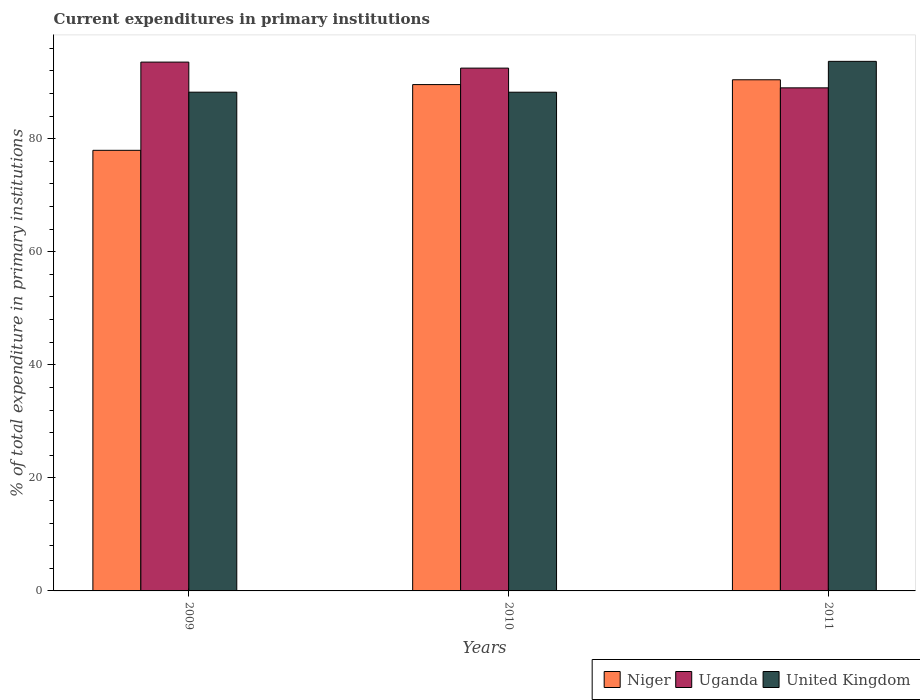How many different coloured bars are there?
Ensure brevity in your answer.  3. How many groups of bars are there?
Offer a very short reply. 3. Are the number of bars per tick equal to the number of legend labels?
Your answer should be compact. Yes. Are the number of bars on each tick of the X-axis equal?
Make the answer very short. Yes. How many bars are there on the 2nd tick from the left?
Your answer should be very brief. 3. How many bars are there on the 2nd tick from the right?
Keep it short and to the point. 3. What is the label of the 1st group of bars from the left?
Your response must be concise. 2009. What is the current expenditures in primary institutions in Uganda in 2010?
Ensure brevity in your answer.  92.48. Across all years, what is the maximum current expenditures in primary institutions in Niger?
Your answer should be compact. 90.42. Across all years, what is the minimum current expenditures in primary institutions in Uganda?
Make the answer very short. 88.99. In which year was the current expenditures in primary institutions in Niger maximum?
Make the answer very short. 2011. In which year was the current expenditures in primary institutions in Uganda minimum?
Your answer should be very brief. 2011. What is the total current expenditures in primary institutions in Niger in the graph?
Your answer should be compact. 257.93. What is the difference between the current expenditures in primary institutions in United Kingdom in 2009 and that in 2011?
Offer a terse response. -5.45. What is the difference between the current expenditures in primary institutions in United Kingdom in 2010 and the current expenditures in primary institutions in Uganda in 2009?
Provide a succinct answer. -5.33. What is the average current expenditures in primary institutions in Niger per year?
Offer a very short reply. 85.98. In the year 2010, what is the difference between the current expenditures in primary institutions in Uganda and current expenditures in primary institutions in Niger?
Your answer should be compact. 2.92. In how many years, is the current expenditures in primary institutions in Uganda greater than 52 %?
Your answer should be compact. 3. What is the ratio of the current expenditures in primary institutions in United Kingdom in 2010 to that in 2011?
Ensure brevity in your answer.  0.94. Is the current expenditures in primary institutions in Uganda in 2010 less than that in 2011?
Give a very brief answer. No. What is the difference between the highest and the second highest current expenditures in primary institutions in Niger?
Offer a very short reply. 0.85. What is the difference between the highest and the lowest current expenditures in primary institutions in Niger?
Offer a terse response. 12.48. In how many years, is the current expenditures in primary institutions in Niger greater than the average current expenditures in primary institutions in Niger taken over all years?
Give a very brief answer. 2. What does the 3rd bar from the right in 2010 represents?
Give a very brief answer. Niger. How many years are there in the graph?
Make the answer very short. 3. Does the graph contain any zero values?
Your answer should be compact. No. Where does the legend appear in the graph?
Keep it short and to the point. Bottom right. How are the legend labels stacked?
Your response must be concise. Horizontal. What is the title of the graph?
Offer a very short reply. Current expenditures in primary institutions. What is the label or title of the Y-axis?
Your answer should be very brief. % of total expenditure in primary institutions. What is the % of total expenditure in primary institutions of Niger in 2009?
Give a very brief answer. 77.94. What is the % of total expenditure in primary institutions in Uganda in 2009?
Provide a succinct answer. 93.55. What is the % of total expenditure in primary institutions in United Kingdom in 2009?
Give a very brief answer. 88.23. What is the % of total expenditure in primary institutions in Niger in 2010?
Provide a succinct answer. 89.57. What is the % of total expenditure in primary institutions in Uganda in 2010?
Your response must be concise. 92.48. What is the % of total expenditure in primary institutions of United Kingdom in 2010?
Ensure brevity in your answer.  88.22. What is the % of total expenditure in primary institutions in Niger in 2011?
Provide a short and direct response. 90.42. What is the % of total expenditure in primary institutions in Uganda in 2011?
Offer a very short reply. 88.99. What is the % of total expenditure in primary institutions of United Kingdom in 2011?
Provide a short and direct response. 93.68. Across all years, what is the maximum % of total expenditure in primary institutions of Niger?
Provide a short and direct response. 90.42. Across all years, what is the maximum % of total expenditure in primary institutions in Uganda?
Provide a short and direct response. 93.55. Across all years, what is the maximum % of total expenditure in primary institutions in United Kingdom?
Your response must be concise. 93.68. Across all years, what is the minimum % of total expenditure in primary institutions in Niger?
Provide a succinct answer. 77.94. Across all years, what is the minimum % of total expenditure in primary institutions in Uganda?
Your answer should be very brief. 88.99. Across all years, what is the minimum % of total expenditure in primary institutions in United Kingdom?
Give a very brief answer. 88.22. What is the total % of total expenditure in primary institutions of Niger in the graph?
Make the answer very short. 257.93. What is the total % of total expenditure in primary institutions of Uganda in the graph?
Your answer should be very brief. 275.02. What is the total % of total expenditure in primary institutions of United Kingdom in the graph?
Provide a succinct answer. 270.12. What is the difference between the % of total expenditure in primary institutions of Niger in 2009 and that in 2010?
Keep it short and to the point. -11.63. What is the difference between the % of total expenditure in primary institutions of Uganda in 2009 and that in 2010?
Offer a terse response. 1.06. What is the difference between the % of total expenditure in primary institutions of United Kingdom in 2009 and that in 2010?
Offer a very short reply. 0.01. What is the difference between the % of total expenditure in primary institutions of Niger in 2009 and that in 2011?
Provide a short and direct response. -12.48. What is the difference between the % of total expenditure in primary institutions in Uganda in 2009 and that in 2011?
Make the answer very short. 4.55. What is the difference between the % of total expenditure in primary institutions in United Kingdom in 2009 and that in 2011?
Provide a short and direct response. -5.45. What is the difference between the % of total expenditure in primary institutions of Niger in 2010 and that in 2011?
Make the answer very short. -0.85. What is the difference between the % of total expenditure in primary institutions of Uganda in 2010 and that in 2011?
Keep it short and to the point. 3.49. What is the difference between the % of total expenditure in primary institutions in United Kingdom in 2010 and that in 2011?
Provide a short and direct response. -5.46. What is the difference between the % of total expenditure in primary institutions in Niger in 2009 and the % of total expenditure in primary institutions in Uganda in 2010?
Ensure brevity in your answer.  -14.54. What is the difference between the % of total expenditure in primary institutions in Niger in 2009 and the % of total expenditure in primary institutions in United Kingdom in 2010?
Ensure brevity in your answer.  -10.28. What is the difference between the % of total expenditure in primary institutions in Uganda in 2009 and the % of total expenditure in primary institutions in United Kingdom in 2010?
Ensure brevity in your answer.  5.33. What is the difference between the % of total expenditure in primary institutions in Niger in 2009 and the % of total expenditure in primary institutions in Uganda in 2011?
Offer a terse response. -11.05. What is the difference between the % of total expenditure in primary institutions of Niger in 2009 and the % of total expenditure in primary institutions of United Kingdom in 2011?
Your answer should be compact. -15.74. What is the difference between the % of total expenditure in primary institutions of Uganda in 2009 and the % of total expenditure in primary institutions of United Kingdom in 2011?
Your response must be concise. -0.13. What is the difference between the % of total expenditure in primary institutions in Niger in 2010 and the % of total expenditure in primary institutions in Uganda in 2011?
Your response must be concise. 0.58. What is the difference between the % of total expenditure in primary institutions in Niger in 2010 and the % of total expenditure in primary institutions in United Kingdom in 2011?
Offer a terse response. -4.11. What is the difference between the % of total expenditure in primary institutions in Uganda in 2010 and the % of total expenditure in primary institutions in United Kingdom in 2011?
Ensure brevity in your answer.  -1.2. What is the average % of total expenditure in primary institutions in Niger per year?
Keep it short and to the point. 85.98. What is the average % of total expenditure in primary institutions of Uganda per year?
Your response must be concise. 91.67. What is the average % of total expenditure in primary institutions in United Kingdom per year?
Your response must be concise. 90.04. In the year 2009, what is the difference between the % of total expenditure in primary institutions in Niger and % of total expenditure in primary institutions in Uganda?
Your response must be concise. -15.61. In the year 2009, what is the difference between the % of total expenditure in primary institutions in Niger and % of total expenditure in primary institutions in United Kingdom?
Offer a very short reply. -10.29. In the year 2009, what is the difference between the % of total expenditure in primary institutions of Uganda and % of total expenditure in primary institutions of United Kingdom?
Your answer should be compact. 5.32. In the year 2010, what is the difference between the % of total expenditure in primary institutions of Niger and % of total expenditure in primary institutions of Uganda?
Keep it short and to the point. -2.92. In the year 2010, what is the difference between the % of total expenditure in primary institutions of Niger and % of total expenditure in primary institutions of United Kingdom?
Provide a short and direct response. 1.35. In the year 2010, what is the difference between the % of total expenditure in primary institutions of Uganda and % of total expenditure in primary institutions of United Kingdom?
Your answer should be very brief. 4.26. In the year 2011, what is the difference between the % of total expenditure in primary institutions in Niger and % of total expenditure in primary institutions in Uganda?
Offer a terse response. 1.43. In the year 2011, what is the difference between the % of total expenditure in primary institutions in Niger and % of total expenditure in primary institutions in United Kingdom?
Offer a very short reply. -3.26. In the year 2011, what is the difference between the % of total expenditure in primary institutions in Uganda and % of total expenditure in primary institutions in United Kingdom?
Keep it short and to the point. -4.69. What is the ratio of the % of total expenditure in primary institutions in Niger in 2009 to that in 2010?
Give a very brief answer. 0.87. What is the ratio of the % of total expenditure in primary institutions of Uganda in 2009 to that in 2010?
Provide a short and direct response. 1.01. What is the ratio of the % of total expenditure in primary institutions of United Kingdom in 2009 to that in 2010?
Your answer should be very brief. 1. What is the ratio of the % of total expenditure in primary institutions of Niger in 2009 to that in 2011?
Make the answer very short. 0.86. What is the ratio of the % of total expenditure in primary institutions of Uganda in 2009 to that in 2011?
Offer a terse response. 1.05. What is the ratio of the % of total expenditure in primary institutions in United Kingdom in 2009 to that in 2011?
Give a very brief answer. 0.94. What is the ratio of the % of total expenditure in primary institutions in Niger in 2010 to that in 2011?
Ensure brevity in your answer.  0.99. What is the ratio of the % of total expenditure in primary institutions of Uganda in 2010 to that in 2011?
Your answer should be very brief. 1.04. What is the ratio of the % of total expenditure in primary institutions of United Kingdom in 2010 to that in 2011?
Give a very brief answer. 0.94. What is the difference between the highest and the second highest % of total expenditure in primary institutions in Niger?
Your response must be concise. 0.85. What is the difference between the highest and the second highest % of total expenditure in primary institutions in Uganda?
Keep it short and to the point. 1.06. What is the difference between the highest and the second highest % of total expenditure in primary institutions of United Kingdom?
Your answer should be compact. 5.45. What is the difference between the highest and the lowest % of total expenditure in primary institutions in Niger?
Offer a terse response. 12.48. What is the difference between the highest and the lowest % of total expenditure in primary institutions in Uganda?
Your response must be concise. 4.55. What is the difference between the highest and the lowest % of total expenditure in primary institutions of United Kingdom?
Your answer should be very brief. 5.46. 